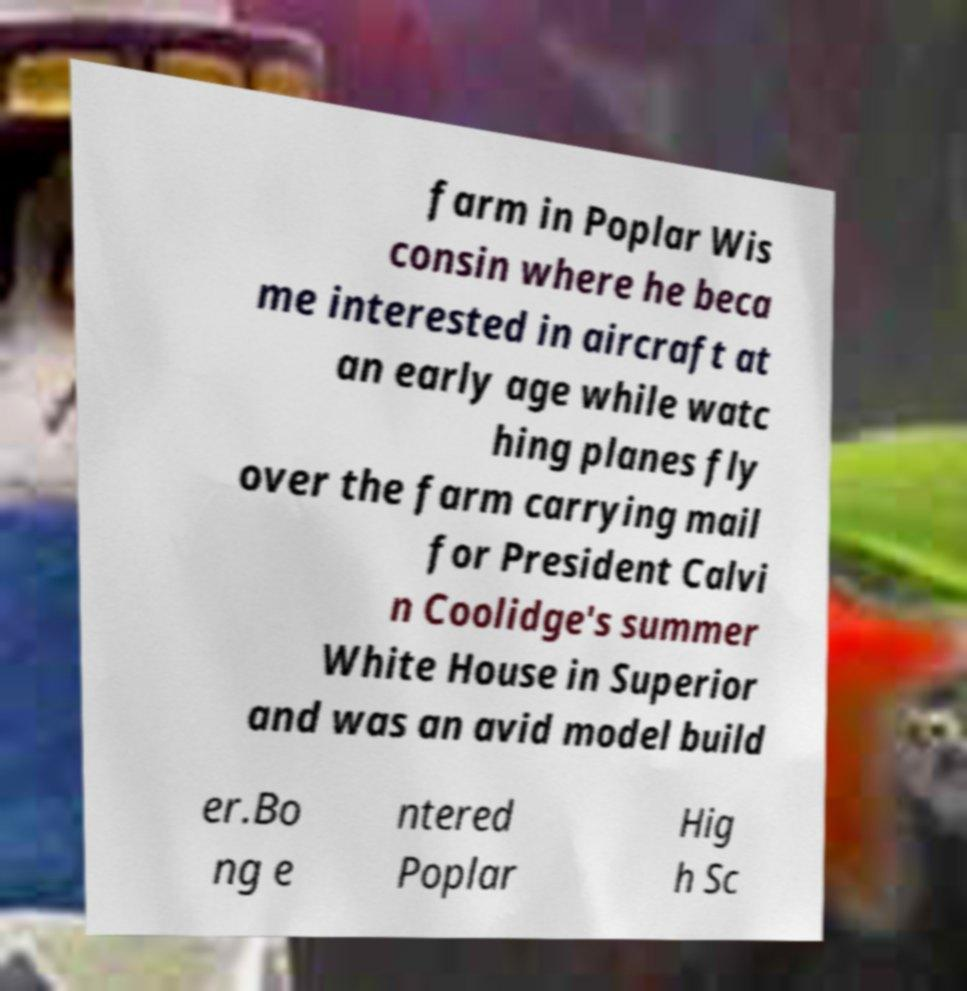For documentation purposes, I need the text within this image transcribed. Could you provide that? farm in Poplar Wis consin where he beca me interested in aircraft at an early age while watc hing planes fly over the farm carrying mail for President Calvi n Coolidge's summer White House in Superior and was an avid model build er.Bo ng e ntered Poplar Hig h Sc 